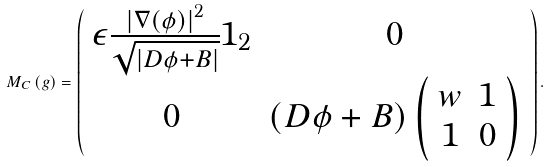Convert formula to latex. <formula><loc_0><loc_0><loc_500><loc_500>M _ { C } \left ( g \right ) = \left ( \begin{array} [ c ] { c c } \epsilon \frac { \left | \nabla \left ( \phi \right ) \right | ^ { 2 } } { \sqrt { \left | D \phi + B \right | } } 1 _ { 2 } & 0 \\ 0 & \left ( D \phi + B \right ) \left ( \begin{array} [ c ] { c c } w & 1 \\ 1 & 0 \end{array} \right ) \end{array} \right ) .</formula> 